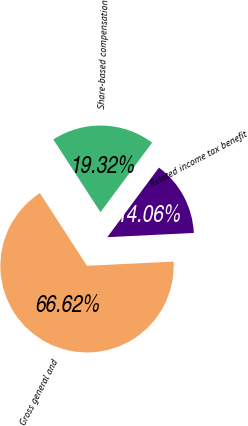<chart> <loc_0><loc_0><loc_500><loc_500><pie_chart><fcel>Gross general and<fcel>Share-based compensation<fcel>Related income tax benefit<nl><fcel>66.62%<fcel>19.32%<fcel>14.06%<nl></chart> 